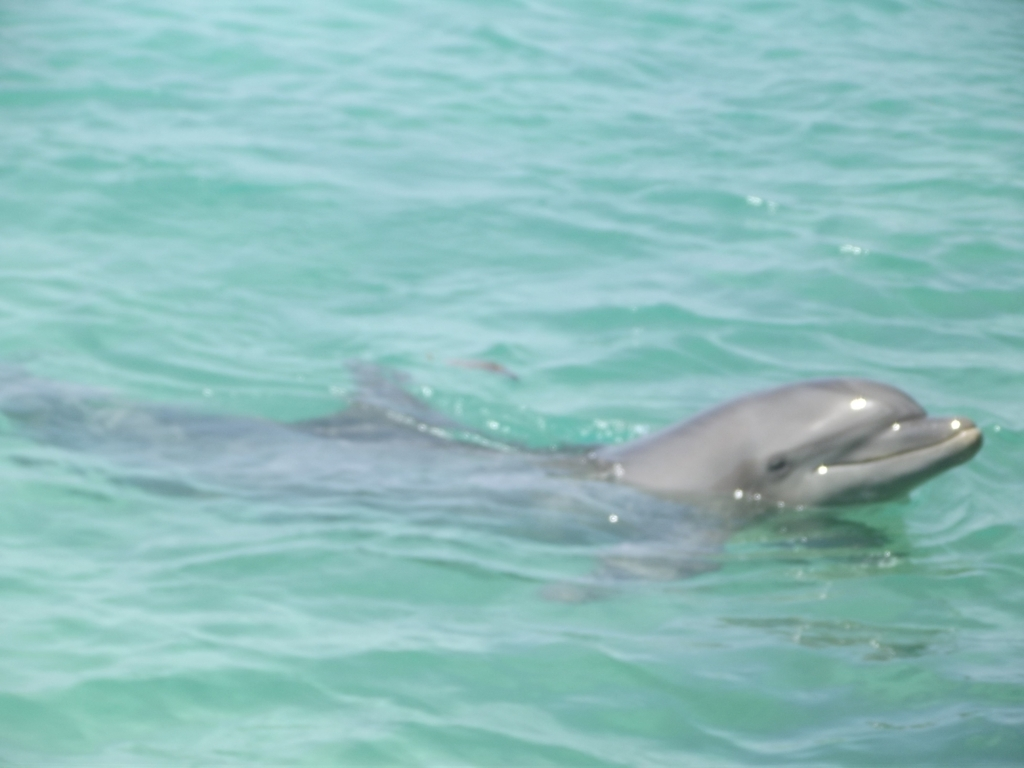Could you suggest how this photo could be improved? To enhance this photo, one could adjust the exposure to avoid overexposure and bring out more of the detail in the water and the dolphin's skin. Also, using a faster shutter speed might help to get a sharper focus on the dolphin, which would improve clarity and give the image a crisper look. If possible, taking the photo during a time of day when the light is less harsh could also provide more balanced natural lighting. 